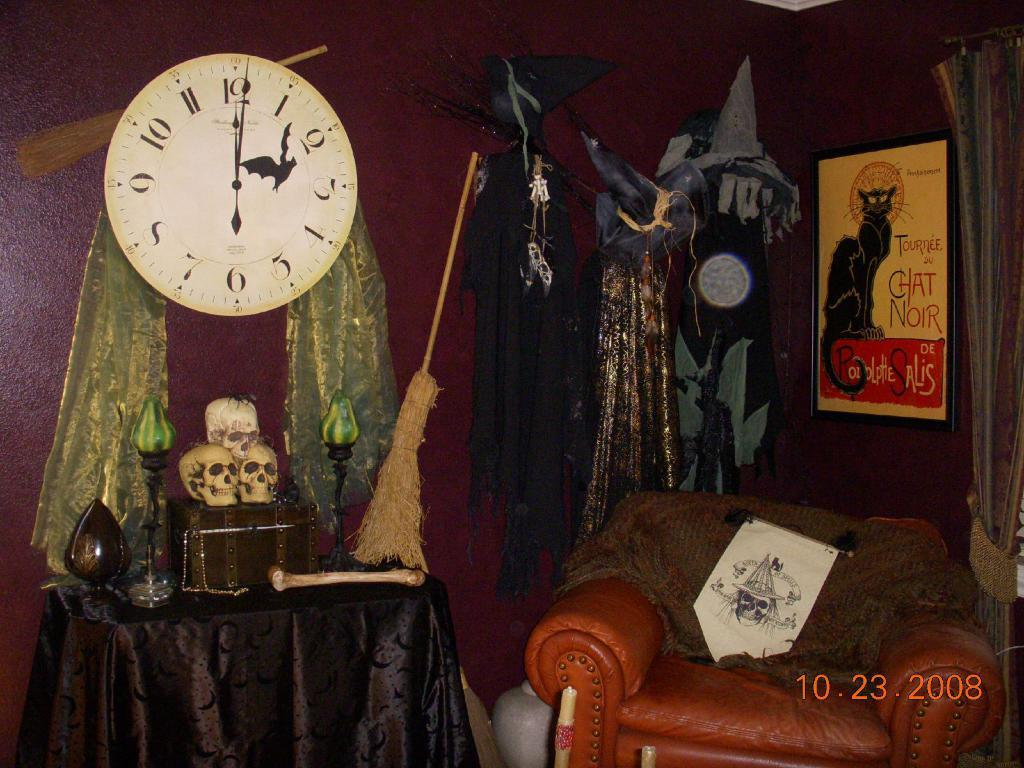Provide a one-sentence caption for the provided image. A picture of several Halloween props including a broom, skulls and candles taken on October 23, 2008. 